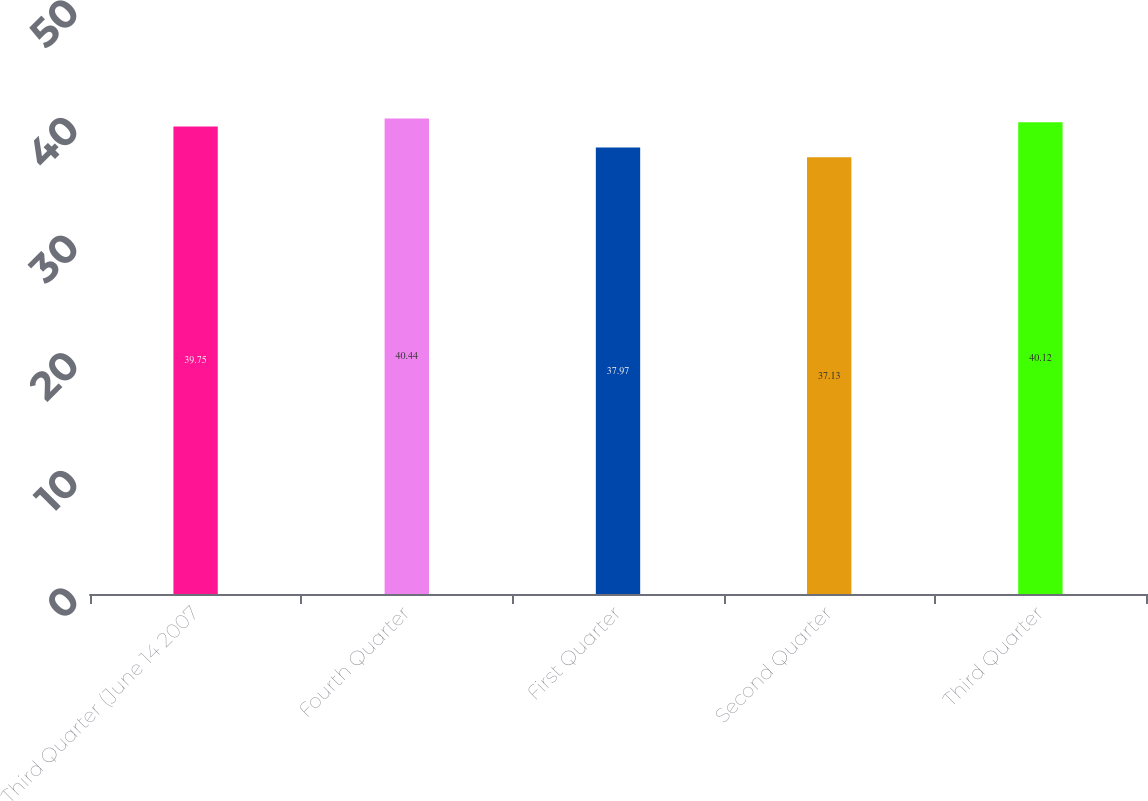Convert chart to OTSL. <chart><loc_0><loc_0><loc_500><loc_500><bar_chart><fcel>Third Quarter (June 14 2007<fcel>Fourth Quarter<fcel>First Quarter<fcel>Second Quarter<fcel>Third Quarter<nl><fcel>39.75<fcel>40.44<fcel>37.97<fcel>37.13<fcel>40.12<nl></chart> 